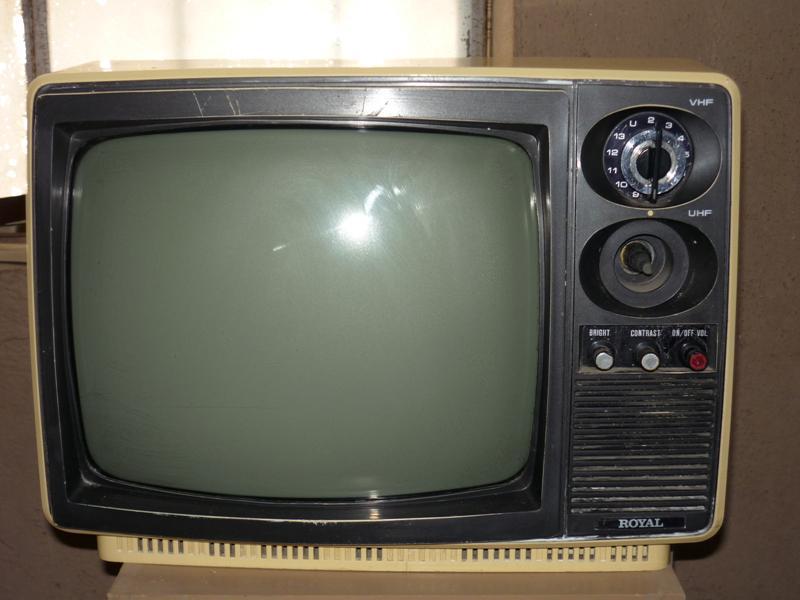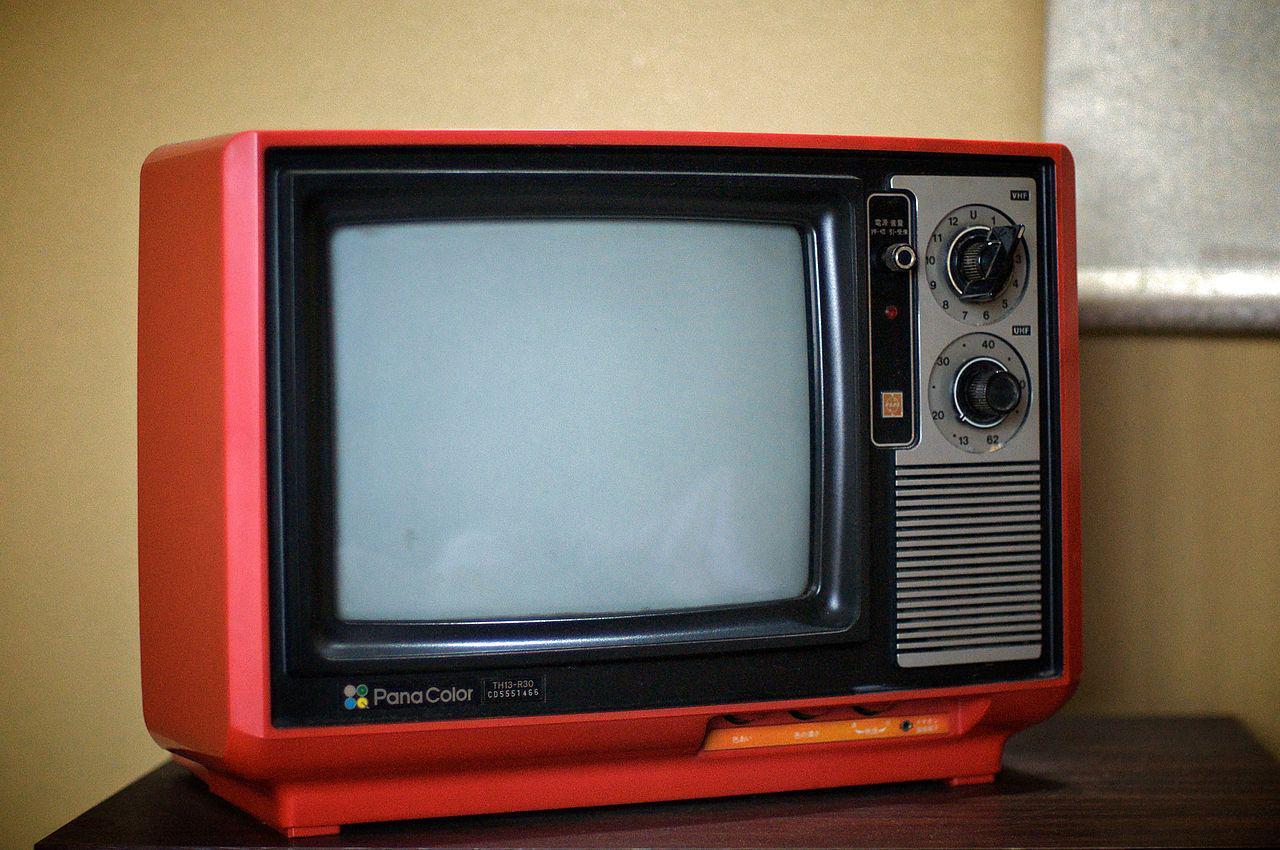The first image is the image on the left, the second image is the image on the right. Assess this claim about the two images: "In one of the images there is a red television with rotary knobs.". Correct or not? Answer yes or no. Yes. The first image is the image on the left, the second image is the image on the right. Given the left and right images, does the statement "The right image contains a TV with a reddish-orange case and two large dials to the right of its screen." hold true? Answer yes or no. Yes. 